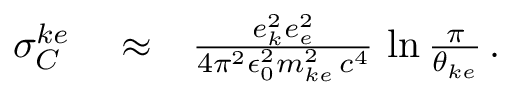<formula> <loc_0><loc_0><loc_500><loc_500>\begin{array} { r l r } { \sigma _ { C } ^ { k e } } & \approx } & { \frac { e _ { k } ^ { 2 } e _ { e } ^ { 2 } } { 4 \pi ^ { 2 } \epsilon _ { 0 } ^ { 2 } m _ { k e } ^ { 2 } \, c ^ { 4 } } \, \ln \frac { \pi } { \theta _ { k e } } \, . } \end{array}</formula> 